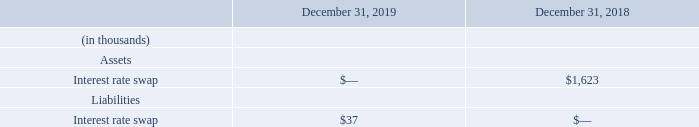6. Financial Instruments
The composition of financial instruments is as follows:
The fair values of the Company’s financial instrument is the amount that would be received in an asset sale or paid to transfer a liability in an orderly transaction between unaffiliated market participants and is recorded using a hierarchical disclosure framework based upon the level of subjectivity of the inputs used in measuring assets and liabilities. The levels are described below:
Level 1: Quoted prices (unadjusted) in active markets that are accessible at the measurement date for assets or liabilities. Level 2: Observable prices that are based on inputs not quoted on active markets, but corroborated by market data. Level 3: Unobservable inputs are used when little or no market data is available.
The Company classifies its financial instrument within Level 2 of the fair value hierarchy on the basis of models utilizing market observable inputs. The interest rate swap has been valued on the basis of valuations provided by third-party pricing services, as derived from standard valuation or pricing models. Market-based observable inputs for the interest rate swap include one month LIBOR-based yield curves over the term of the swap. The Company reviews third-party pricing provider models, key inputs and assumptions and understands the pricing processes at its third-party providers in determining the overall reasonableness of the fair value of its Level 2 financial instruments. The Company also considers the risk of nonperformance by assessing the swap counterparty's credit risk in the estimate of fair value of the interest rate swap. As of December 31, 2019 and 2018, the Company has not made any adjustments to the valuations obtained from its third party pricing providers.
How is the fair value of the company's financial instrument defined? The fair values of the company’s financial instrument is the amount that would be received in an asset sale or paid to transfer a liability in an orderly transaction between unaffiliated market participants and is recorded using a hierarchical disclosure framework based upon the level of subjectivity of the inputs used in measuring assets and liabilities. What was the interest rate swap in 2019 and 2018 respectively?
Answer scale should be: thousand. 0, 1,623. In which year was interest rate swap less than 1,000 thousands? Locate and analyze interest rate swap in row 4
answer: 2019. What was the change in the interest rate swap from 2018 to 2019?
Answer scale should be: thousand. 0 - 1,623
Answer: -1623. What was the average interest rate swap liabilities for 2018 and 2019?
Answer scale should be: thousand. (37 + 0) / 2
Answer: 18.5. What are the 3 levels of subjectivity? Level 1: quoted prices (unadjusted) in active markets that are accessible at the measurement date for assets or liabilities., level 2: observable prices that are based on inputs not quoted on active markets, but corroborated by market data, level 3: unobservable inputs are used when little or no market data is available. 